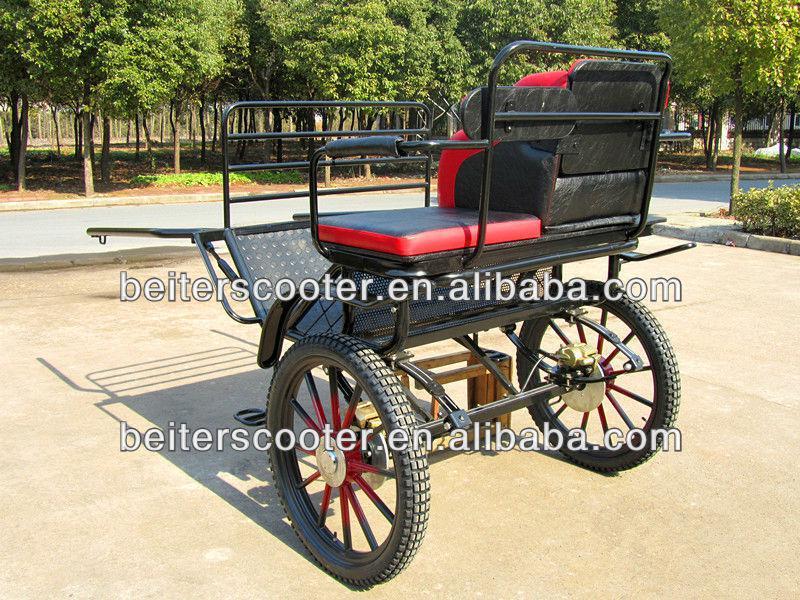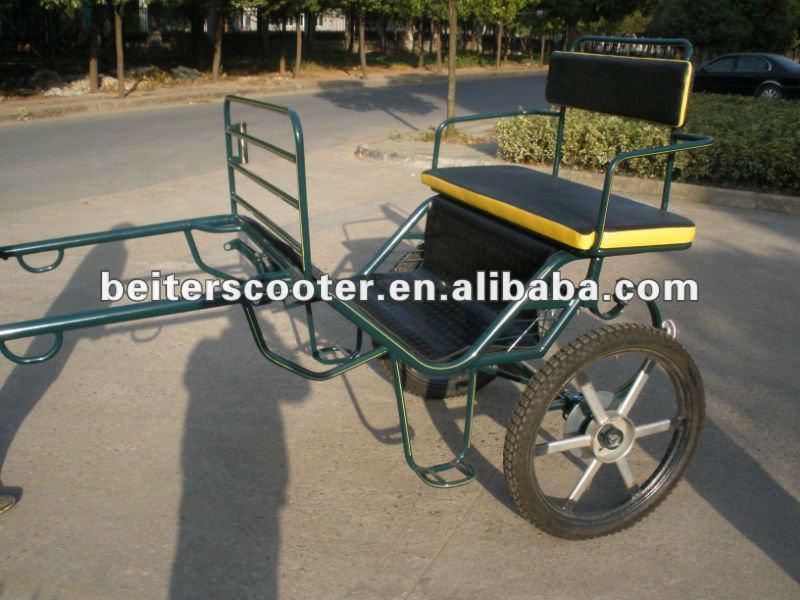The first image is the image on the left, the second image is the image on the right. Evaluate the accuracy of this statement regarding the images: "The front end of one of the carts is on the ground.". Is it true? Answer yes or no. No. The first image is the image on the left, the second image is the image on the right. Assess this claim about the two images: "In one image, the 'handles' of the wagon are tilted to the ground.". Correct or not? Answer yes or no. No. 